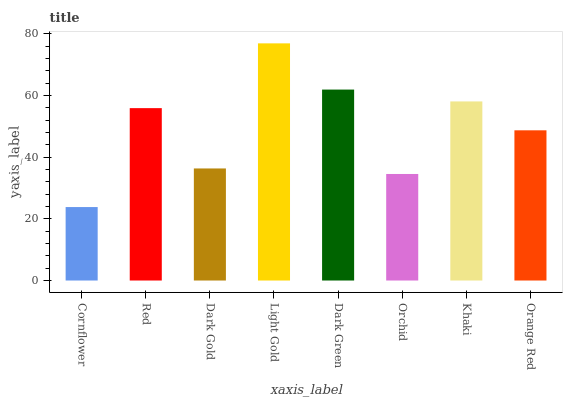Is Cornflower the minimum?
Answer yes or no. Yes. Is Light Gold the maximum?
Answer yes or no. Yes. Is Red the minimum?
Answer yes or no. No. Is Red the maximum?
Answer yes or no. No. Is Red greater than Cornflower?
Answer yes or no. Yes. Is Cornflower less than Red?
Answer yes or no. Yes. Is Cornflower greater than Red?
Answer yes or no. No. Is Red less than Cornflower?
Answer yes or no. No. Is Red the high median?
Answer yes or no. Yes. Is Orange Red the low median?
Answer yes or no. Yes. Is Light Gold the high median?
Answer yes or no. No. Is Red the low median?
Answer yes or no. No. 